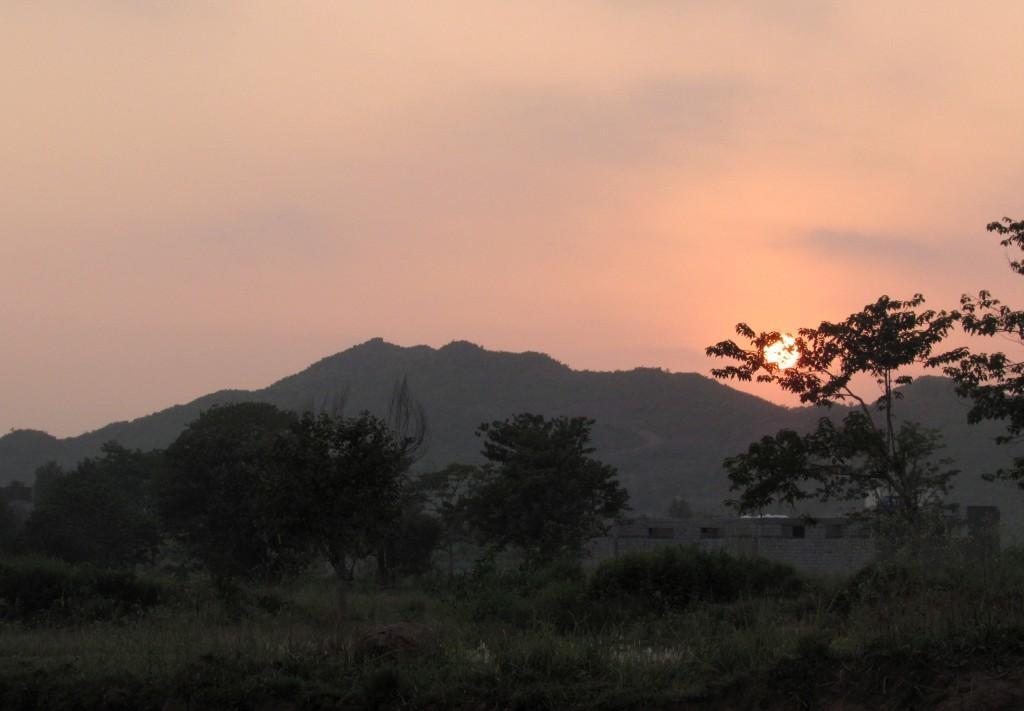In one or two sentences, can you explain what this image depicts? In this image there are trees and a house, in the background of the image there are mountains, at the top of the image there is sun in the sky. 